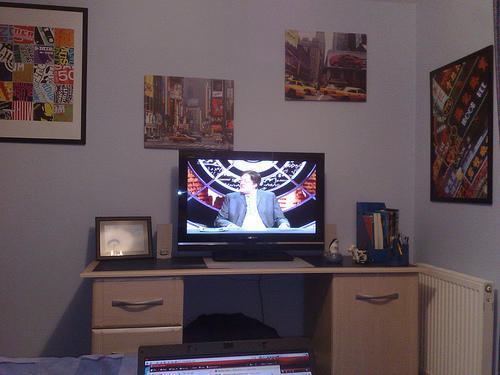How many televisions are in this picture?
Give a very brief answer. 1. How many people are on the television screen?
Give a very brief answer. 1. 